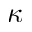<formula> <loc_0><loc_0><loc_500><loc_500>\kappa</formula> 